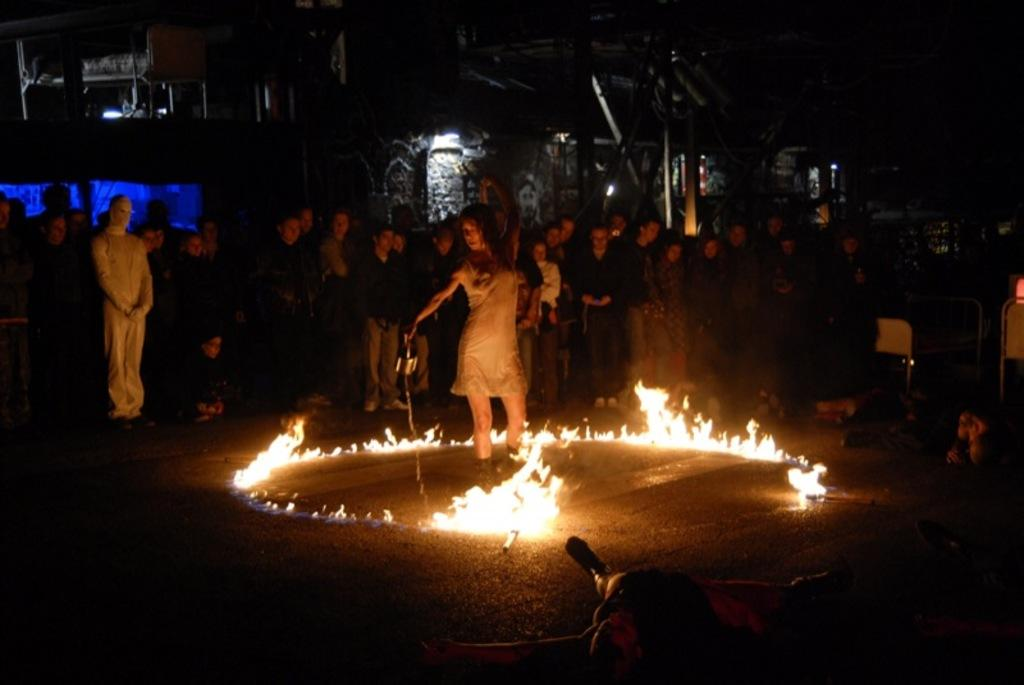What is the girl doing in the image? The girl is performing tricks in the image. Where is the girl located? The girl is on a road. What is happening around the girl? There is fire around the girl. What can be seen in the background of the image? There are people standing and a building in the background of the image. What type of worm can be seen crawling on the girl's hand in the image? There is no worm present in the image; the girl is surrounded by fire. 